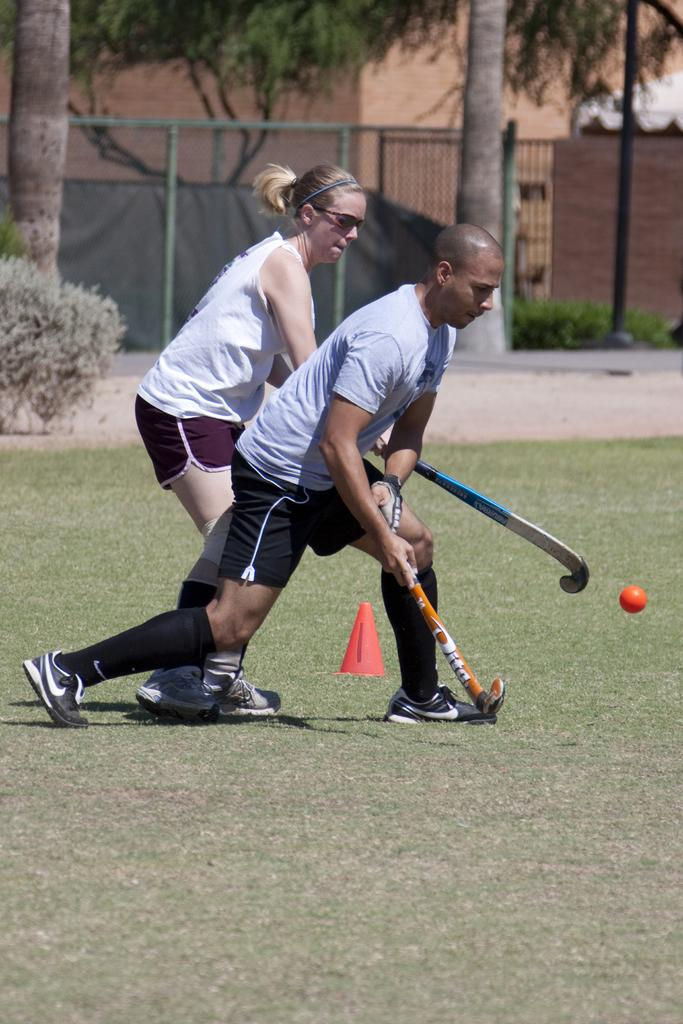How many people are present in the image? There are two people in the image. What object can be seen in the image that is typically used in sports or games? There is a ball in the image. What is the purpose of the traffic cone in the image? The traffic cone in the image is likely used to mark a specific area or provide a warning. What type of surface is visible in the image? There is grass in the image. What type of vegetation can be seen in the image besides grass? There are plants and trees in the image. What type of structure is visible in the image? There are buildings in the image. What type of barrier is present in the image? There is a fence in the image. What type of nation is represented by the rose in the image? There is no rose present in the image, so it is not possible to determine which nation might be represented. What type of cable is used to connect the two people in the image? There is no cable connecting the two people in the image; they are simply standing near each other. 